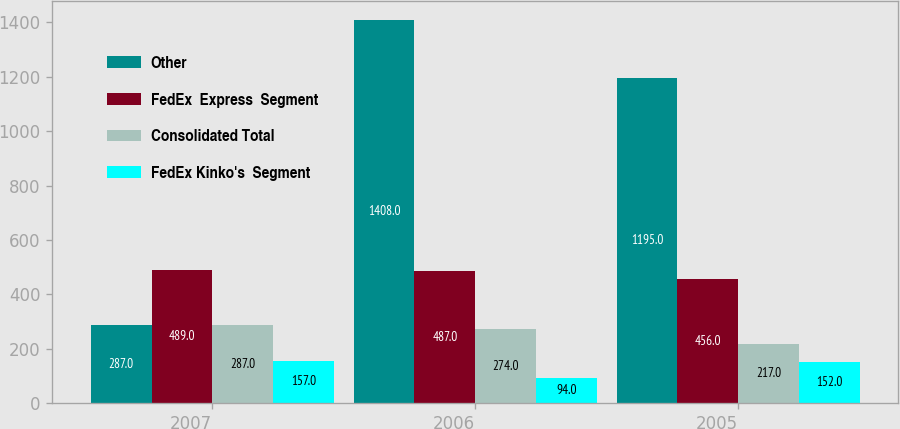Convert chart. <chart><loc_0><loc_0><loc_500><loc_500><stacked_bar_chart><ecel><fcel>2007<fcel>2006<fcel>2005<nl><fcel>Other<fcel>287<fcel>1408<fcel>1195<nl><fcel>FedEx  Express  Segment<fcel>489<fcel>487<fcel>456<nl><fcel>Consolidated Total<fcel>287<fcel>274<fcel>217<nl><fcel>FedEx Kinko's  Segment<fcel>157<fcel>94<fcel>152<nl></chart> 